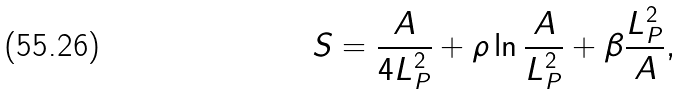<formula> <loc_0><loc_0><loc_500><loc_500>S = \frac { A } { 4 { L } _ { P } ^ { 2 } } + \rho \ln { \frac { A } { L _ { P } ^ { 2 } } } + \beta \frac { L _ { P } ^ { 2 } } { A } ,</formula> 